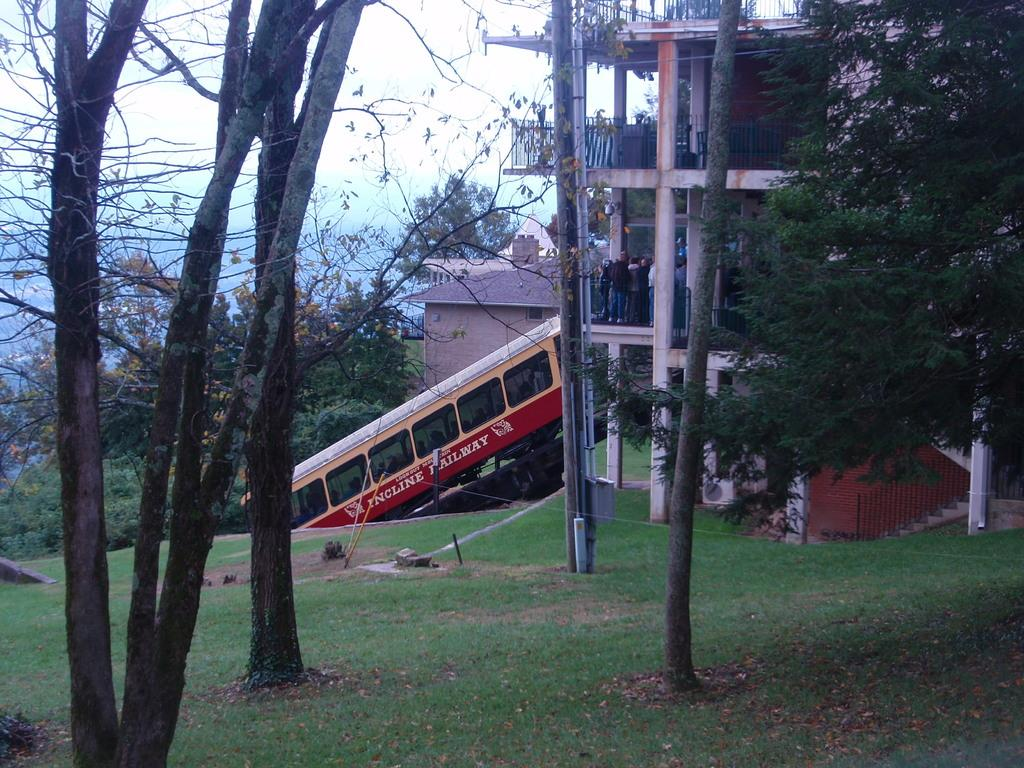What is the main subject of the image? There is a vehicle in the image. Who or what is inside the vehicle? There are people inside the vehicle. What type of natural environment can be seen in the image? There are trees and grass in the image. What type of man-made structures are visible in the image? There are buildings in the image. What can be seen in the background of the image? The sky is visible in the background of the image. Can you tell me how many donkeys are playing in the grass in the image? There are no donkeys present in the image, and therefore no such activity can be observed. What type of camera is being used to take the picture? There is no camera visible in the image, as it is a photograph itself. 